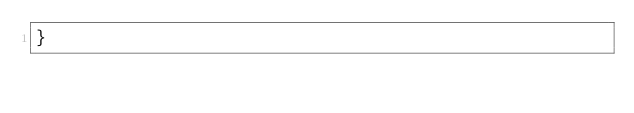<code> <loc_0><loc_0><loc_500><loc_500><_C++_>}
</code> 